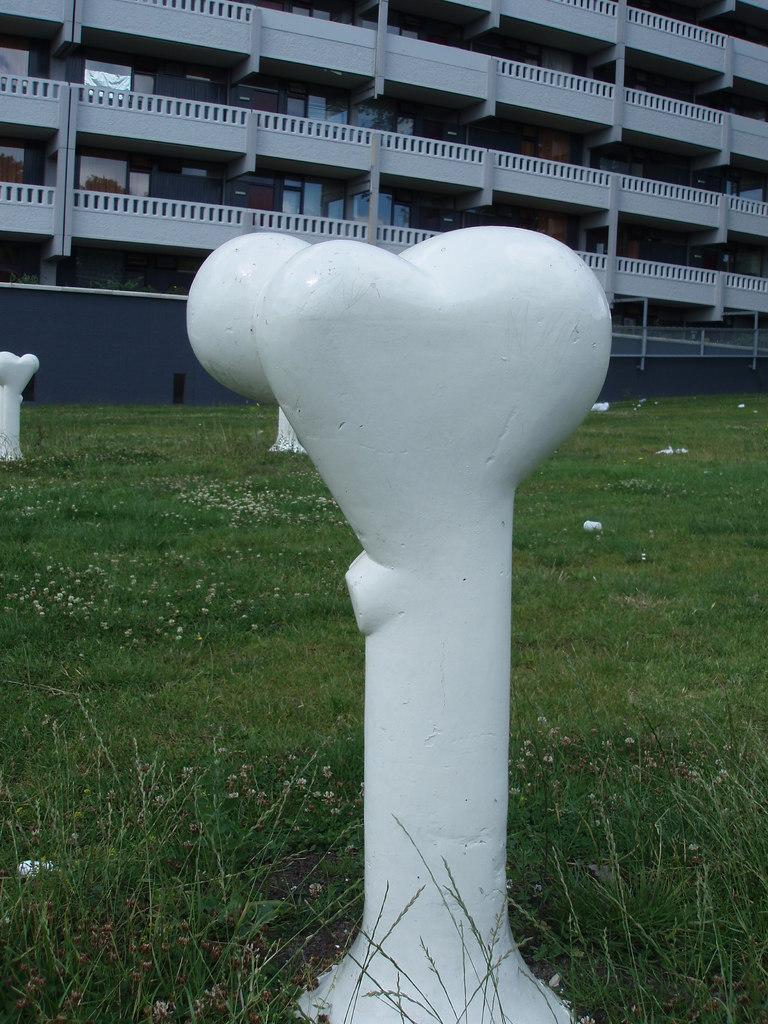Please provide a concise description of this image. In this image I can see few white color statues. Back Side I can see building,windows and balcony. It is in white color. I can see a blue color fencing. In front I can see a green color grass. 